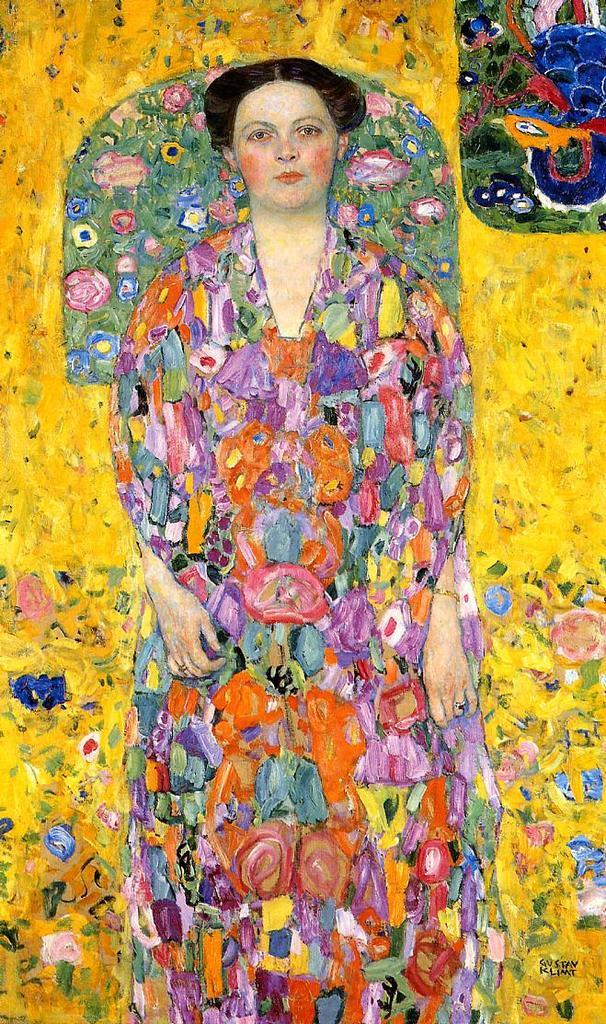What type of artwork is depicted in the image? The image appears to be a painting. Who or what is the main subject in the painting? There is a woman in the painting. What natural elements can be seen in the painting? There are flowers and leaves in the painting. What man-made object is present in the painting? There is a football in the painting. Are there any animals in the painting? Yes, there is a bird in the painting. Can you describe the overall composition of the painting? There are various objects in the painting. What type of songs can be heard playing in the background of the painting? There are no songs or sounds present in the painting, as it is a static visual artwork. 